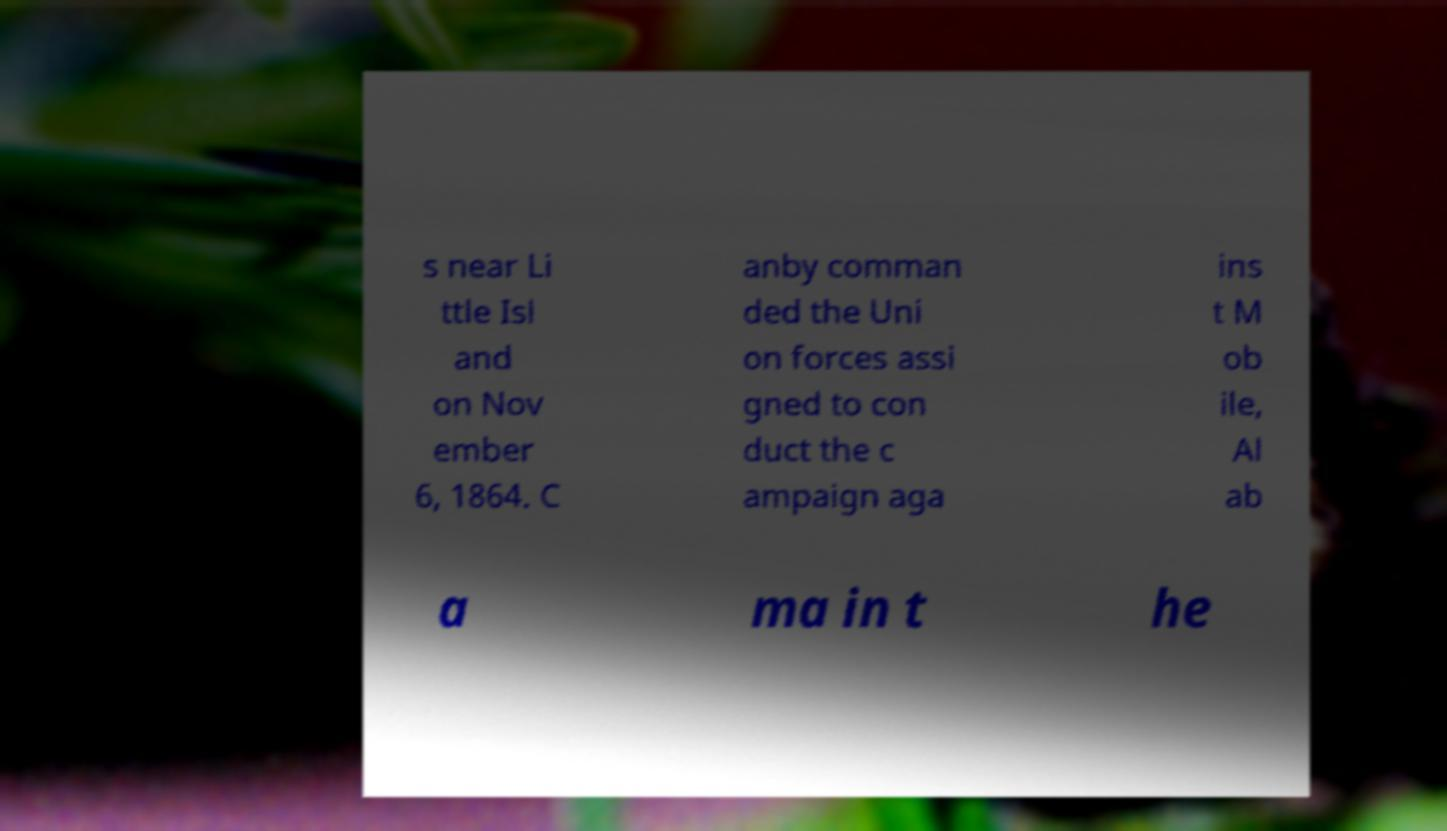Could you assist in decoding the text presented in this image and type it out clearly? s near Li ttle Isl and on Nov ember 6, 1864. C anby comman ded the Uni on forces assi gned to con duct the c ampaign aga ins t M ob ile, Al ab a ma in t he 